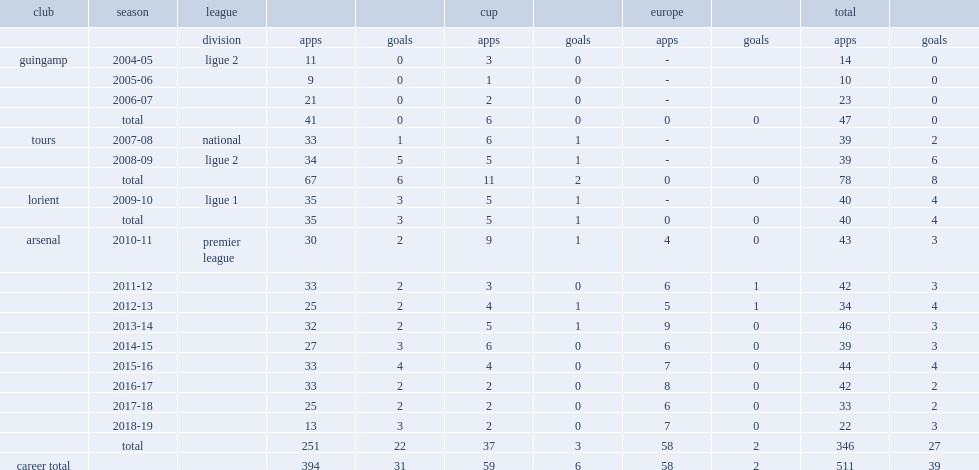Which club did laurent koscielny play for in 2013-14? Arsenal. 